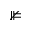<formula> <loc_0><loc_0><loc_500><loc_500>\nVDash</formula> 